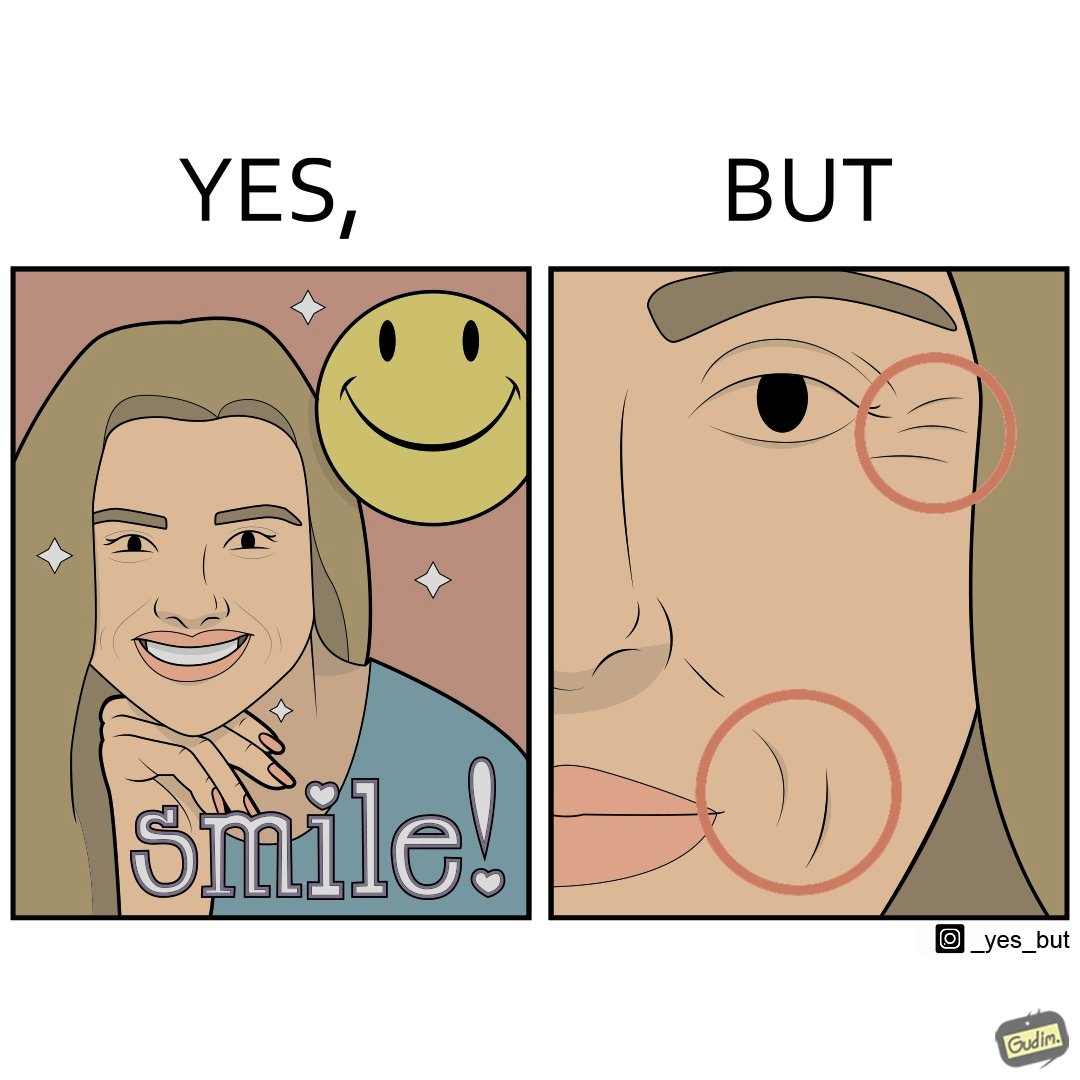Describe the satirical element in this image. The image is ironical because while it suggests people to smile it also shows the wrinkles that can be caused around lips and eyes because of smiling 